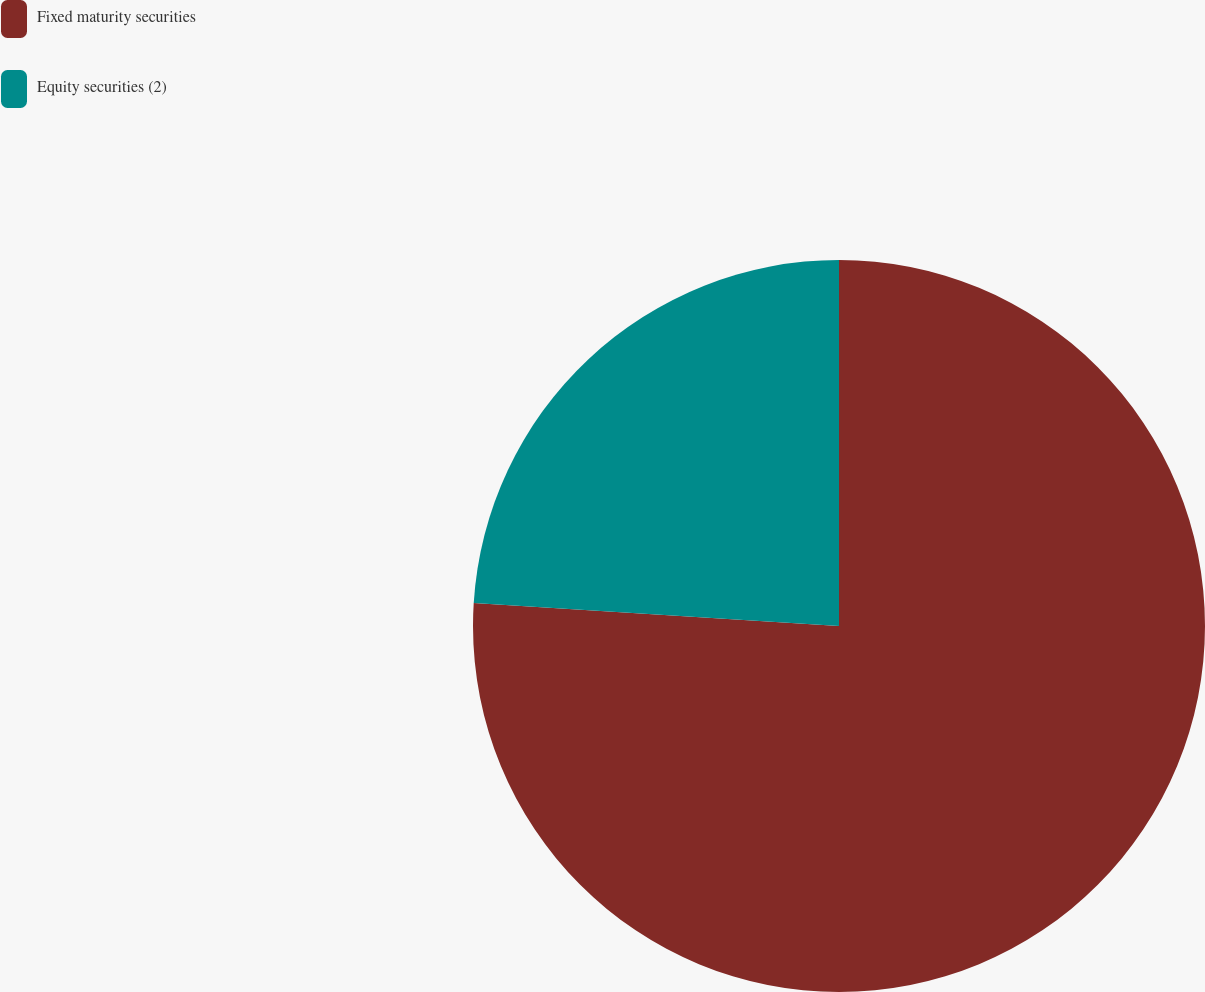Convert chart to OTSL. <chart><loc_0><loc_0><loc_500><loc_500><pie_chart><fcel>Fixed maturity securities<fcel>Equity securities (2)<nl><fcel>76.0%<fcel>24.0%<nl></chart> 